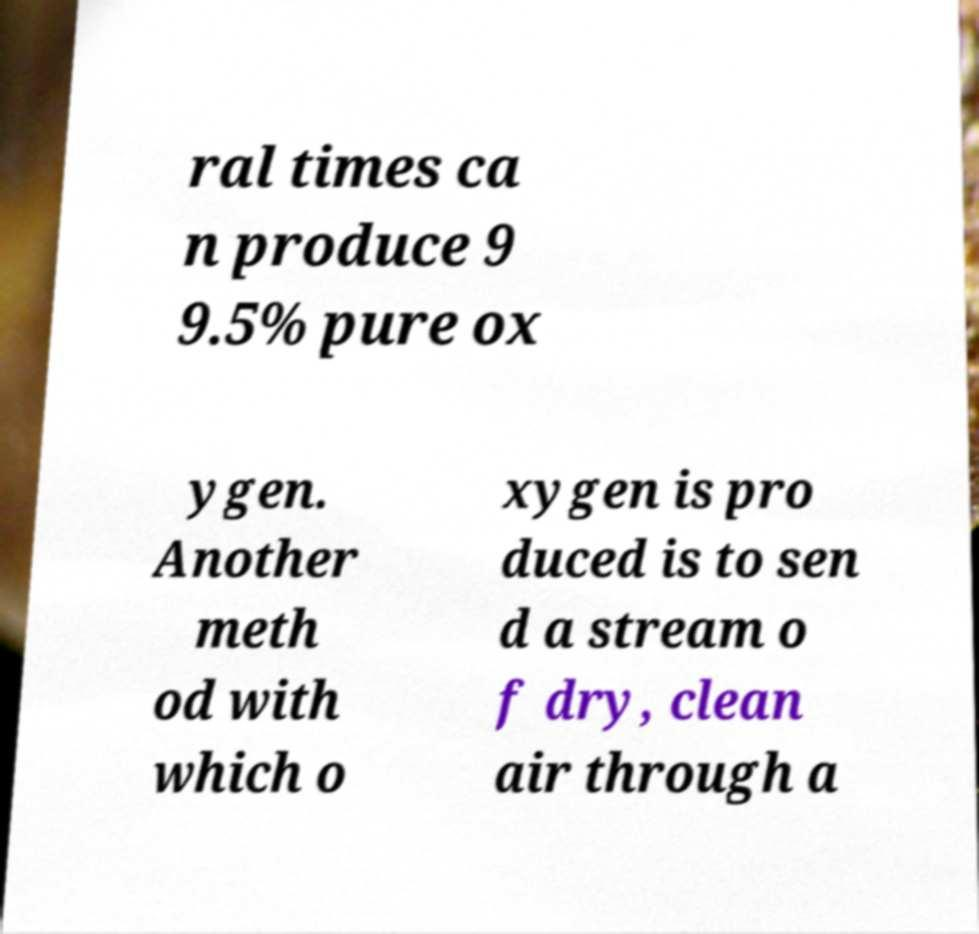Could you assist in decoding the text presented in this image and type it out clearly? ral times ca n produce 9 9.5% pure ox ygen. Another meth od with which o xygen is pro duced is to sen d a stream o f dry, clean air through a 